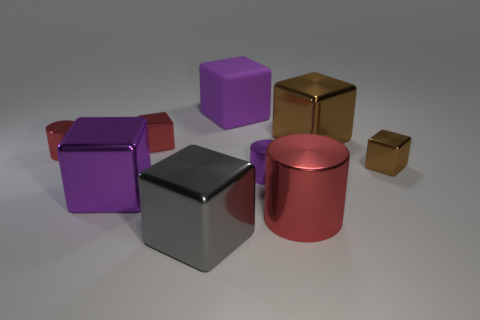Do these objects share a common theme or purpose? The objects do not necessarily share a common theme or purpose. They appear to be geometric shapes commonly used in visualization and rendering tests. These objects are often used to demonstrate shading, lighting, and reflection properties in a controlled environment. 